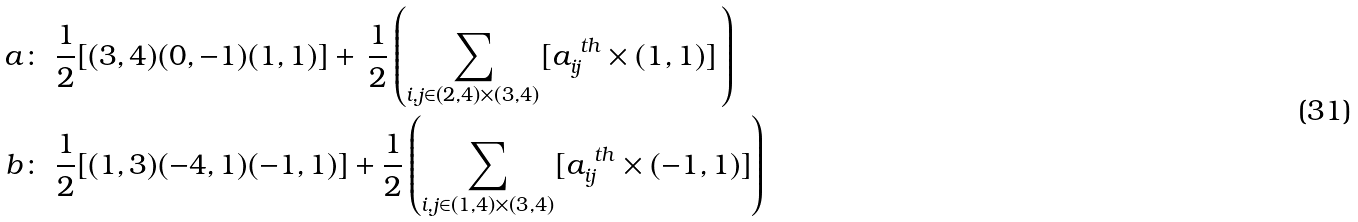Convert formula to latex. <formula><loc_0><loc_0><loc_500><loc_500>a \colon & \ \frac { 1 } { 2 } [ ( 3 , 4 ) ( 0 , - 1 ) ( 1 , 1 ) ] + \, \frac { 1 } { 2 } \left ( \sum _ { i , j \in ( 2 , 4 ) \times ( 3 , 4 ) } [ a _ { i j } ^ { \ t h } \times ( 1 , 1 ) ] \, \right ) \\ b \colon & \ \frac { 1 } { 2 } [ ( 1 , 3 ) ( - 4 , 1 ) ( - 1 , 1 ) ] + \frac { 1 } { 2 } \left ( \sum _ { i , j \in ( 1 , 4 ) \times ( 3 , 4 ) } [ a _ { i j } ^ { \ t h } \times ( - 1 , 1 ) ] \right )</formula> 